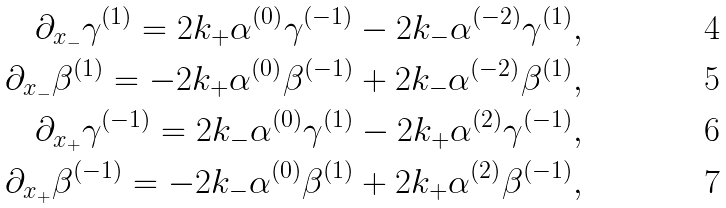Convert formula to latex. <formula><loc_0><loc_0><loc_500><loc_500>\partial _ { x _ { - } } \gamma ^ { ( 1 ) } = 2 k _ { + } \alpha ^ { ( 0 ) } \gamma ^ { ( - 1 ) } - 2 k _ { - } \alpha ^ { ( - 2 ) } \gamma ^ { ( 1 ) } , \\ \partial _ { x _ { - } } \beta ^ { ( 1 ) } = - 2 k _ { + } \alpha ^ { ( 0 ) } \beta ^ { ( - 1 ) } + 2 k _ { - } \alpha ^ { ( - 2 ) } \beta ^ { ( 1 ) } , \\ \partial _ { x _ { + } } \gamma ^ { ( - 1 ) } = 2 k _ { - } \alpha ^ { ( 0 ) } \gamma ^ { ( 1 ) } - 2 k _ { + } \alpha ^ { ( 2 ) } \gamma ^ { ( - 1 ) } , \\ \partial _ { x _ { + } } \beta ^ { ( - 1 ) } = - 2 k _ { - } \alpha ^ { ( 0 ) } \beta ^ { ( 1 ) } + 2 k _ { + } \alpha ^ { ( 2 ) } \beta ^ { ( - 1 ) } ,</formula> 